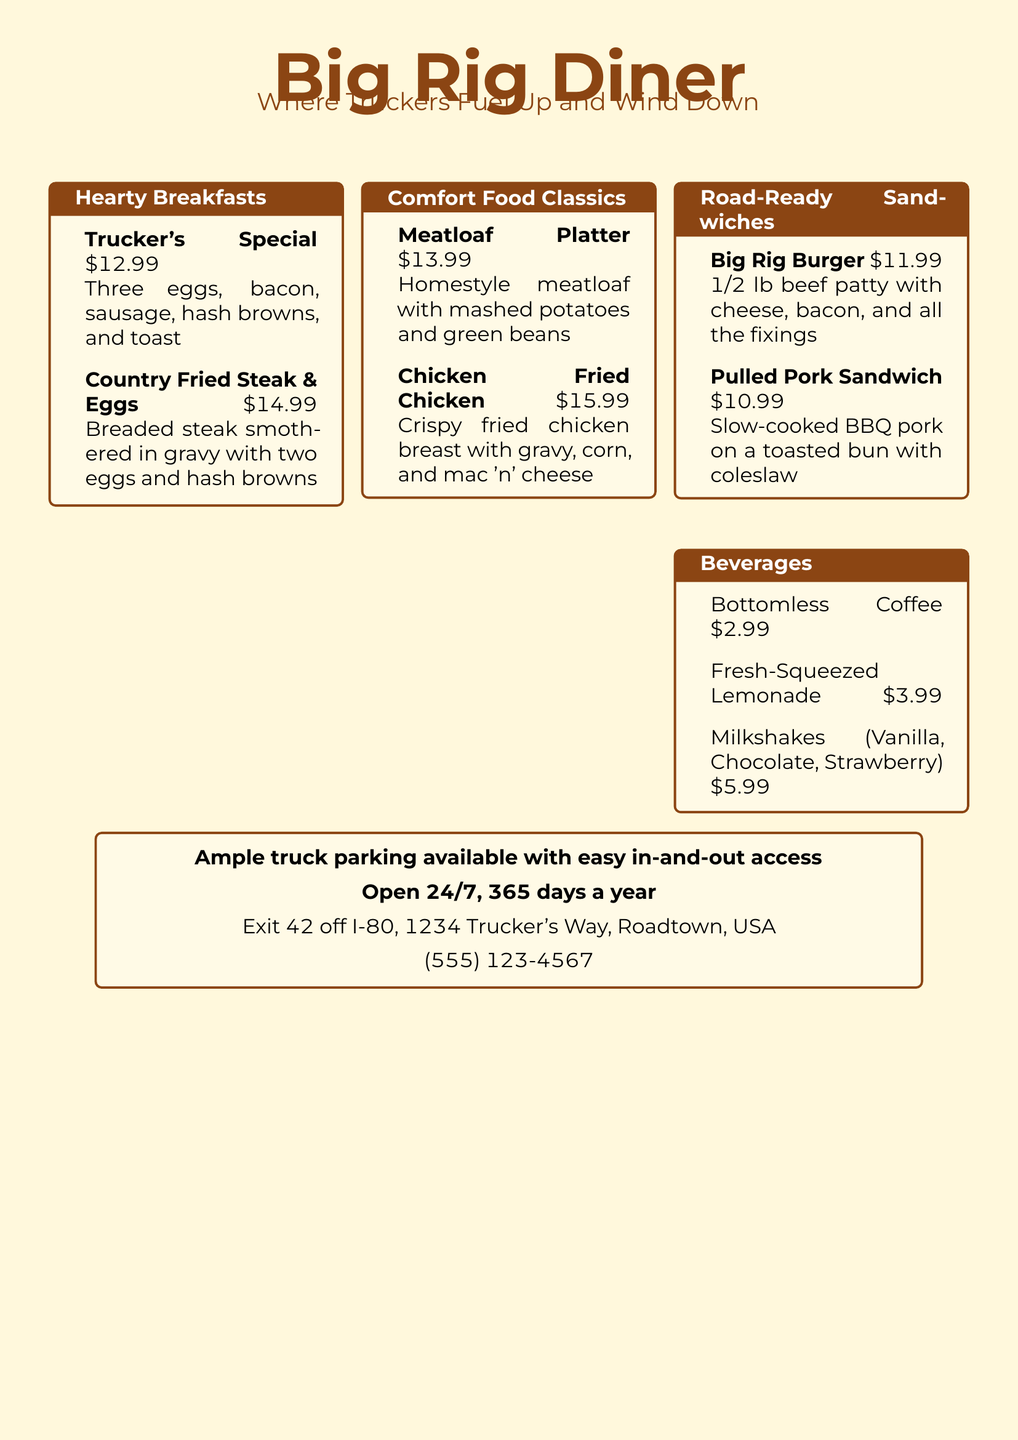What is the name of the diner? The diner is called "Big Rig Diner," as prominently featured at the top of the menu.
Answer: Big Rig Diner What is the price of the Trucker's Special? The price of the Trucker's Special is listed under the Hearty Breakfasts section.
Answer: $12.99 How many types of milkshakes are offered? The Beverages section lists milkshakes as available in three flavors, indicating the variety offered.
Answer: Three What are the operating hours of the diner? The document states the diner is open "24/7, 365 days a year," indicating its availability.
Answer: 24/7, 365 days a year What type of food is the Chicken Fried Chicken served with? The comfort food classic section details the sides that accompany the Chicken Fried Chicken, which are gravy, corn, and mac 'n' cheese.
Answer: Gravy, corn, and mac 'n' cheese What type of meat is in the Big Rig Burger? The Road-Ready Sandwiches section describes the Big Rig Burger, stating it contains a beef patty.
Answer: Beef patty Which item contains a breaded steak? The Hearty Breakfasts section specifies the Country Fried Steak & Eggs as containing a breaded steak.
Answer: Country Fried Steak & Eggs Where is the diner located? The location of the diner is given at the bottom of the document, including the exit number off I-80.
Answer: Exit 42 off I-80, Roadtown, USA What is the price of the Fresh-Squeezed Lemonade? The price for Fresh-Squeezed Lemonade can be found in the Beverages section of the menu.
Answer: $3.99 